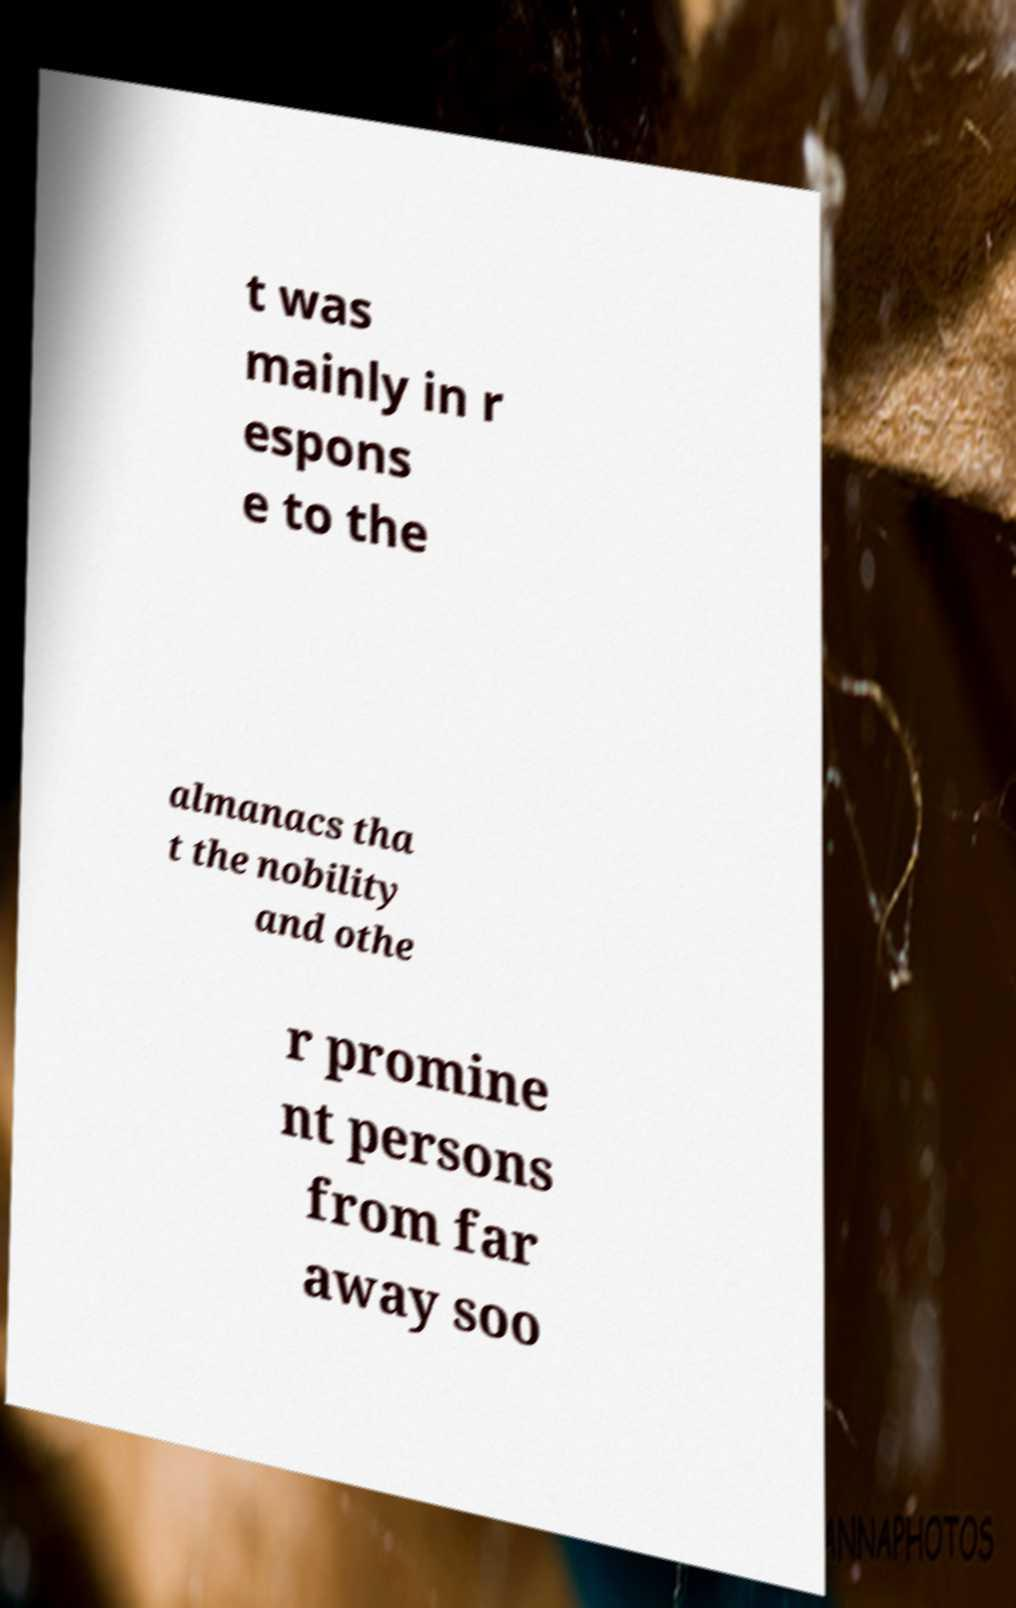Please identify and transcribe the text found in this image. t was mainly in r espons e to the almanacs tha t the nobility and othe r promine nt persons from far away soo 